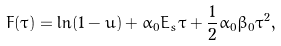<formula> <loc_0><loc_0><loc_500><loc_500>F ( \tau ) = \ln ( 1 - u ) + \alpha _ { 0 } E _ { s } \tau + \frac { 1 } { 2 } \alpha _ { 0 } \beta _ { 0 } \tau ^ { 2 } ,</formula> 